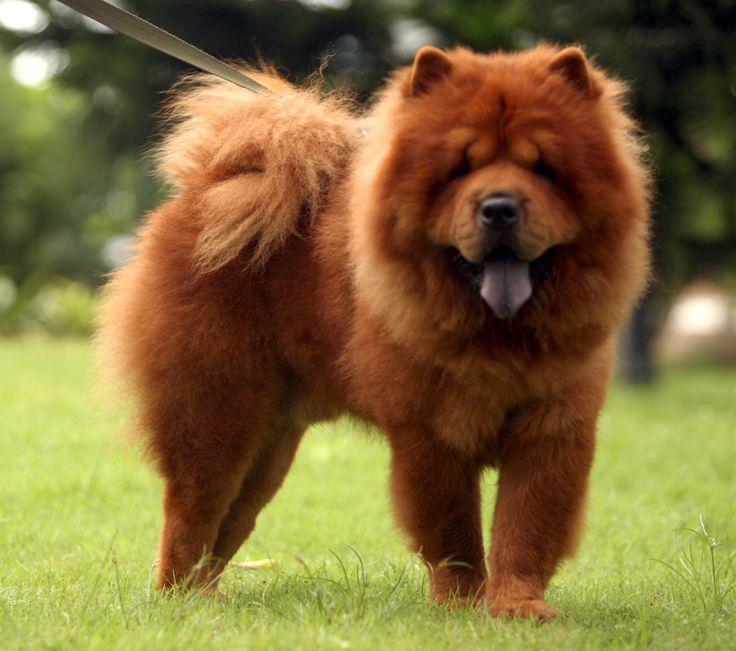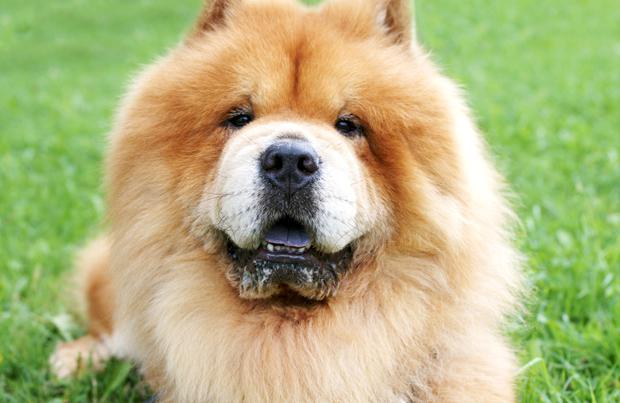The first image is the image on the left, the second image is the image on the right. Evaluate the accuracy of this statement regarding the images: "Each image shows a chow dog standing on grass, and one image shows a dog standing with its body turned leftward.". Is it true? Answer yes or no. No. The first image is the image on the left, the second image is the image on the right. Examine the images to the left and right. Is the description "Two dogs are standing." accurate? Answer yes or no. No. 